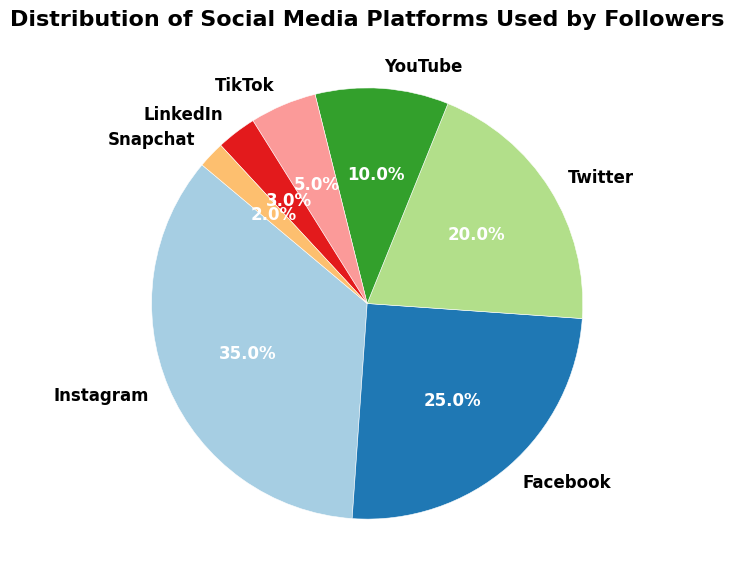what percentage of followers use Instagram and Facebook combined? To find the combined percentage of Instagram and Facebook users, add the given percentages for both platforms: 35% (Instagram) + 25% (Facebook).
Answer: 60% Which platform has the smallest percentage of followers? The platform with the smallest slice in the pie chart and the lowest percentage value is Snapchat, which has 2%.
Answer: Snapchat How many platforms have a higher percentage of followers than YouTube? To find out, identify the platforms with a larger percentage than YouTube's 10%: Instagram (35%), Facebook (25%), and Twitter (20%). That's three platforms.
Answer: 3 What is the difference in percentage of followers between Twitter and TikTok? Subtract TikTok's percentage from Twitter's percentage: 20% (Twitter) - 5% (TikTok).
Answer: 15% What fraction of the followers use LinkedIn? The chart shows that LinkedIn has 3% of followers. In fraction terms, 3% can be expressed as 3/100 or simplified to 3/100.
Answer: 3/100 Which platform's percentage is three times that of Snapchat's? Snapchat's percentage is 2%, so three times that is 2% * 3 = 6%. None of the platforms have precisely 6%, so this question may need review.
Answer: None If you sum the percentages of TikTok, LinkedIn, and Snapchat, what do you get? Add the given percentages for TikTok, LinkedIn, and Snapchat: 5% (TikTok) + 3% (LinkedIn) + 2% (Snapchat) = 10%.
Answer: 10% Is the percentage of followers using Twitter closer to that of Facebook or YouTube? Twitter has 20% of followers. Facebook has 25%, and YouTube has 10%. Calculate the absolute differences:
Answer: YouTube Which platform has approximately one-third the followers of Instagram? Find one-third of Instagram's percentage: 35% / 3 ≈ 11.67%. The closest platform to this value is YouTube with 10%.
Answer: YouTube What is the sum of the percentages of the four largest platforms? Identify the four platforms with the highest percentages: Instagram (35%), Facebook (25%), Twitter (20%), and YouTube (10%). Add these values: 35% + 25% + 20% + 10% = 90%.
Answer: 90% 